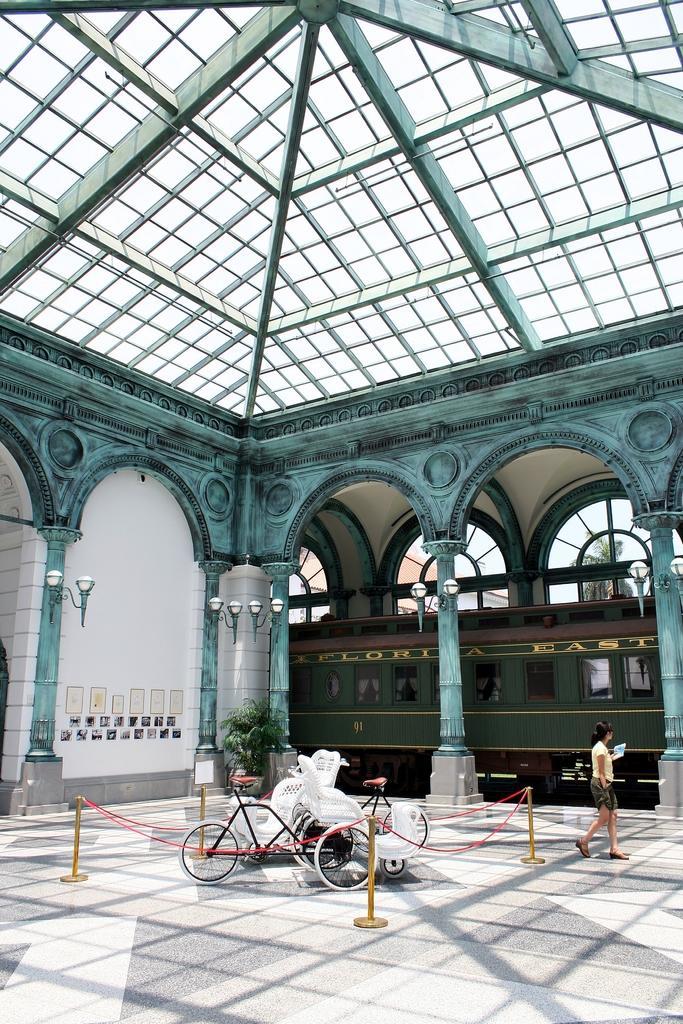How would you summarize this image in a sentence or two? At the bottom of this image, there is a floor, on which there are bicycles parked. Around them, there is a fence. On the right side, there is a person walking. In the background, there are lights attached to the pillars, there are windows and other objects. 